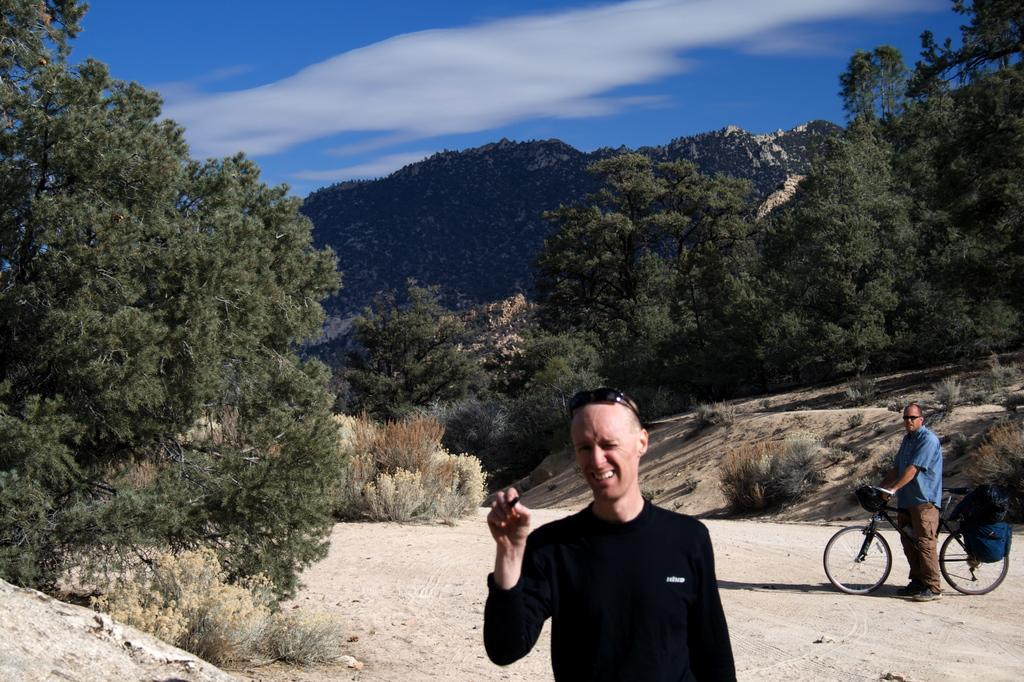What is the main subject of the image? There is a man standing in the image. Where is the man standing? The man is standing in trees. Can you describe the second man in the image? The second man is standing behind the first man and is holding a bicycle. What can be seen in the background of the image? There are hills visible in the background of the image. What type of waste can be seen on the ground in the image? There is no waste visible on the ground in the image. What adjustment is the man making to his bicycle in the image? There is no indication that the man is making any adjustments to his bicycle in the image. 